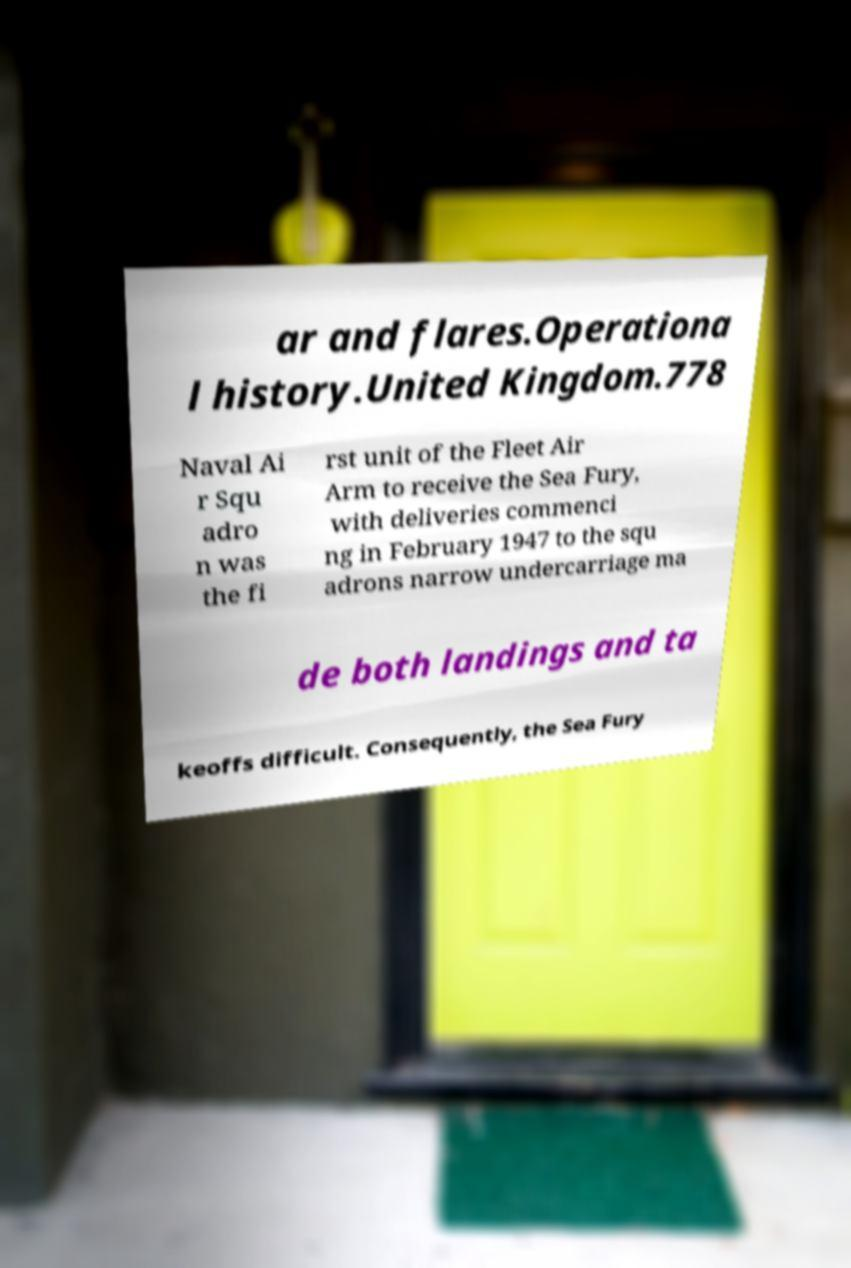Can you accurately transcribe the text from the provided image for me? ar and flares.Operationa l history.United Kingdom.778 Naval Ai r Squ adro n was the fi rst unit of the Fleet Air Arm to receive the Sea Fury, with deliveries commenci ng in February 1947 to the squ adrons narrow undercarriage ma de both landings and ta keoffs difficult. Consequently, the Sea Fury 